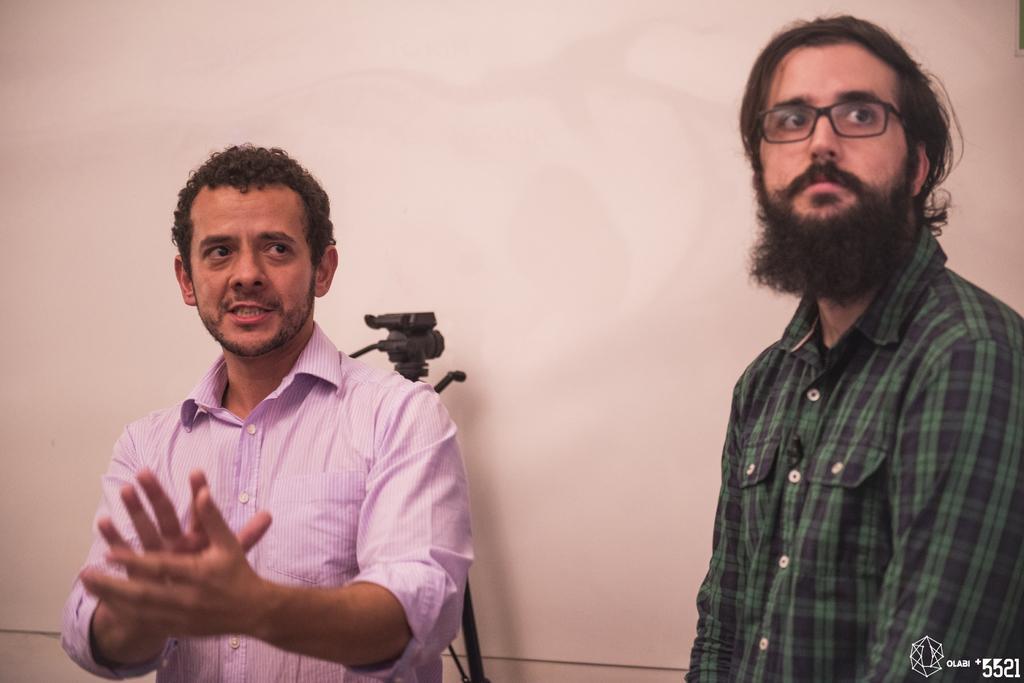In one or two sentences, can you explain what this image depicts? In this picture I can see couple of men standing and we see a camera stand on the back and a man clapping with his hands and another man wore spectacles on his face and we see a white color background. 